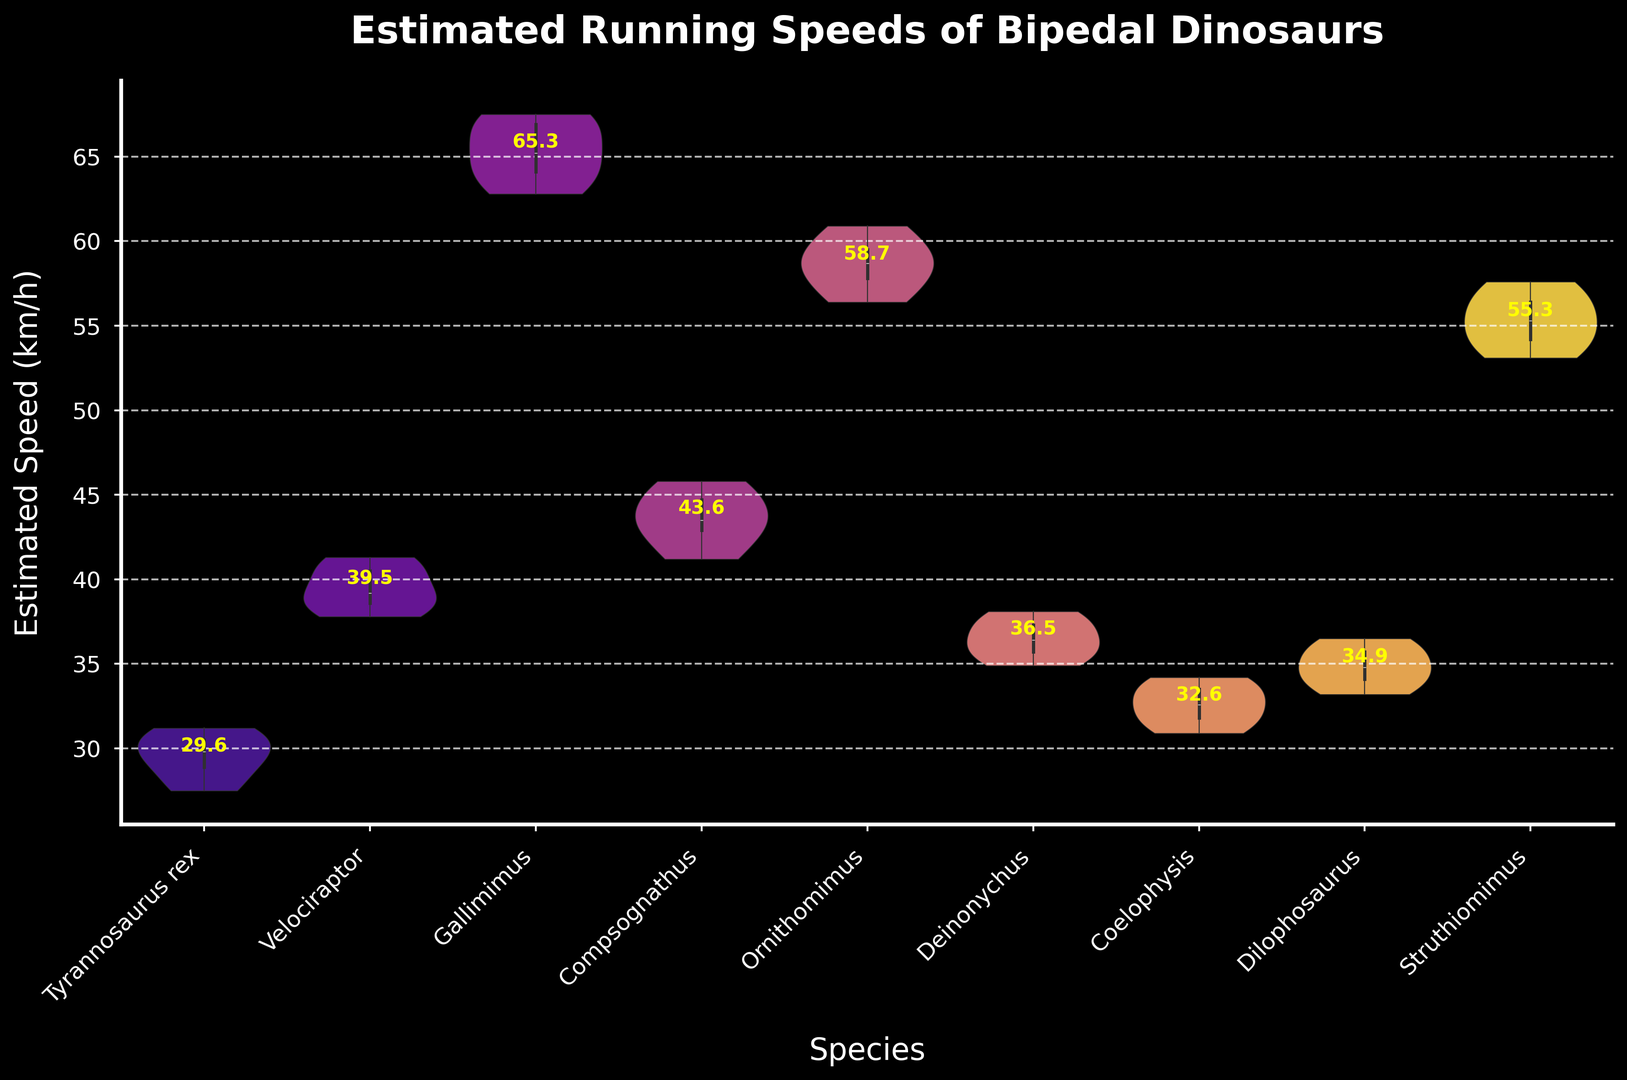What's the species with the highest estimated running speed? Look for the peak of the violin plots on the y-axis representing estimated speed. Gallimimus reaches a peak around 67.5 km/h.
Answer: Gallimimus Which species has the lowest median estimated running speed? Locate the horizontal line within each violin plot representing the median. Coelophysis and Dilophosaurus both have medians around 34 km/h.
Answer: Coelophysis, Dilophosaurus Compare the width of the violin plots for Gallimimus and Tyrannosaurus rex. Which species shows more variation in speeds? Width represents the distribution span. Gallimimus has a wider plot indicating higher variation compared to Tyrannosaurus rex.
Answer: Gallimimus What is the approximate average estimated speed for Velociraptor? Identify the numeric annotation for Velociraptor's average speed above the violin plot, which is around 39.5 km/h.
Answer: 39.5 Which species shows the narrowest range of estimated running speeds? The narrowest range is indicated by the thinnest violin plot along the y-axis. Tyrannosaurus rex has a narrow range compared to other species.
Answer: Tyrannosaurus rex Between Deinonychus and Struthiomimus, which species has a higher median speed? Compare the median lines in the violin plots. Struthiomimus's median line is higher than Deinonychus's.
Answer: Struthiomimus What is the difference in the maximum estimated speeds between Ornithomimus and Compsognathus? Maximum speeds can be estimated from the top of the violin plots. Ornithomimus peaks around 60.9 km/h and Compsognathus around 45.8 km/h. The difference is 60.9 - 45.8 = 15.1 km/h.
Answer: 15.1 km/h How is the data distribution inside the violin plot for Coelophysis visually represented? The distribution is depicted by the shape of the violin plot. Coelophysis has a symmetrical plot with a slight bulge at both ends, indicating most data points are concentrated near the median with few extremes.
Answer: Symmetrical with slight bulges Which dinosaur species' estimated speeds are represented in the plot with a color closer to purple? Observe the color scheme. Gallimimus plots are presented in colors closer to purple in the 'plasma' palette.
Answer: Gallimimus What is the estimated mean running speed for Struthiomimus? By checking the numeric annotations, Struthiomimus's mean speed is shown around 55.3 km/h.
Answer: 55.3 